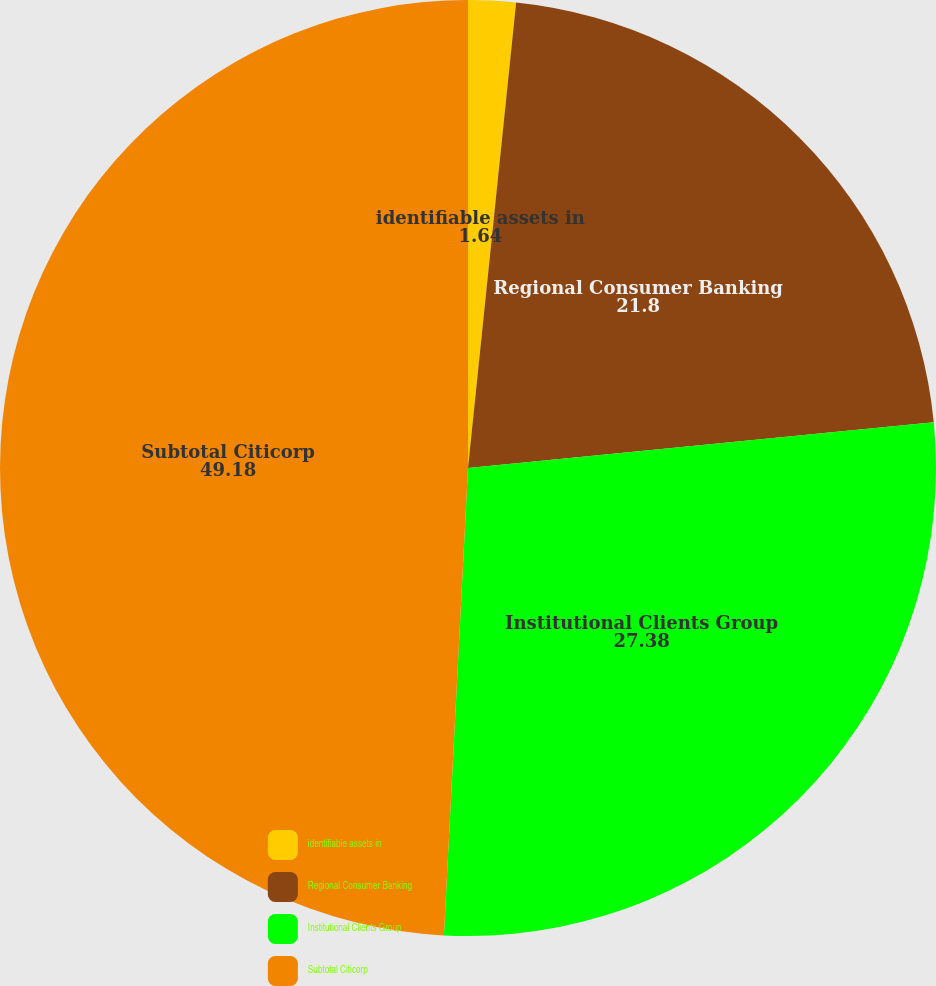Convert chart to OTSL. <chart><loc_0><loc_0><loc_500><loc_500><pie_chart><fcel>identifiable assets in<fcel>Regional Consumer Banking<fcel>Institutional Clients Group<fcel>Subtotal Citicorp<nl><fcel>1.64%<fcel>21.8%<fcel>27.38%<fcel>49.18%<nl></chart> 